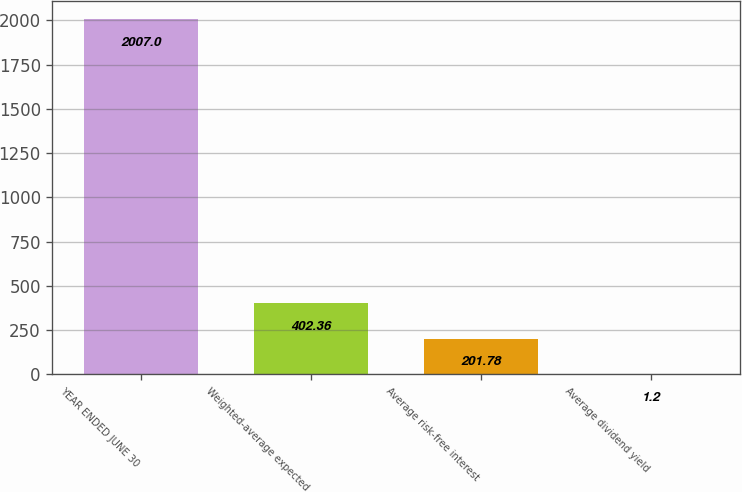Convert chart. <chart><loc_0><loc_0><loc_500><loc_500><bar_chart><fcel>YEAR ENDED JUNE 30<fcel>Weighted-average expected<fcel>Average risk-free interest<fcel>Average dividend yield<nl><fcel>2007<fcel>402.36<fcel>201.78<fcel>1.2<nl></chart> 